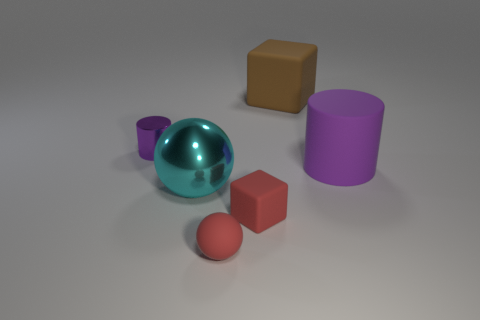Add 2 small purple metal things. How many objects exist? 8 Subtract all cubes. How many objects are left? 4 Subtract 1 cubes. How many cubes are left? 1 Add 4 large matte cylinders. How many large matte cylinders exist? 5 Subtract all red spheres. How many spheres are left? 1 Subtract 0 brown cylinders. How many objects are left? 6 Subtract all gray blocks. Subtract all blue balls. How many blocks are left? 2 Subtract all matte spheres. Subtract all matte spheres. How many objects are left? 4 Add 1 large cyan metal things. How many large cyan metal things are left? 2 